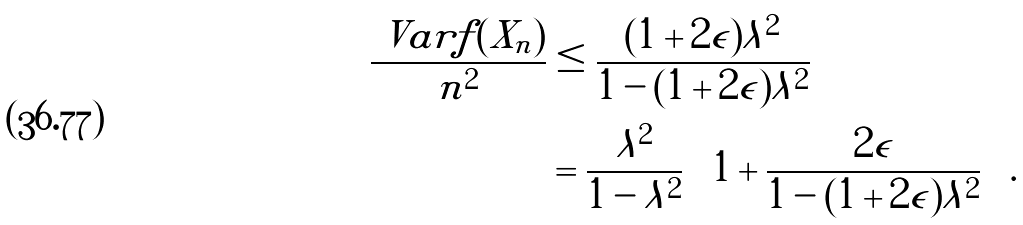Convert formula to latex. <formula><loc_0><loc_0><loc_500><loc_500>\frac { \ V a r f ( X _ { n } ) } { n ^ { 2 } } & \leq \frac { ( 1 + 2 \epsilon ) \lambda ^ { 2 } } { 1 - ( 1 + 2 \epsilon ) \lambda ^ { 2 } } \\ & = \frac { \lambda ^ { 2 } } { 1 - \lambda ^ { 2 } } \left ( 1 + \frac { 2 \epsilon } { 1 - ( 1 + 2 \epsilon ) \lambda ^ { 2 } } \right ) .</formula> 